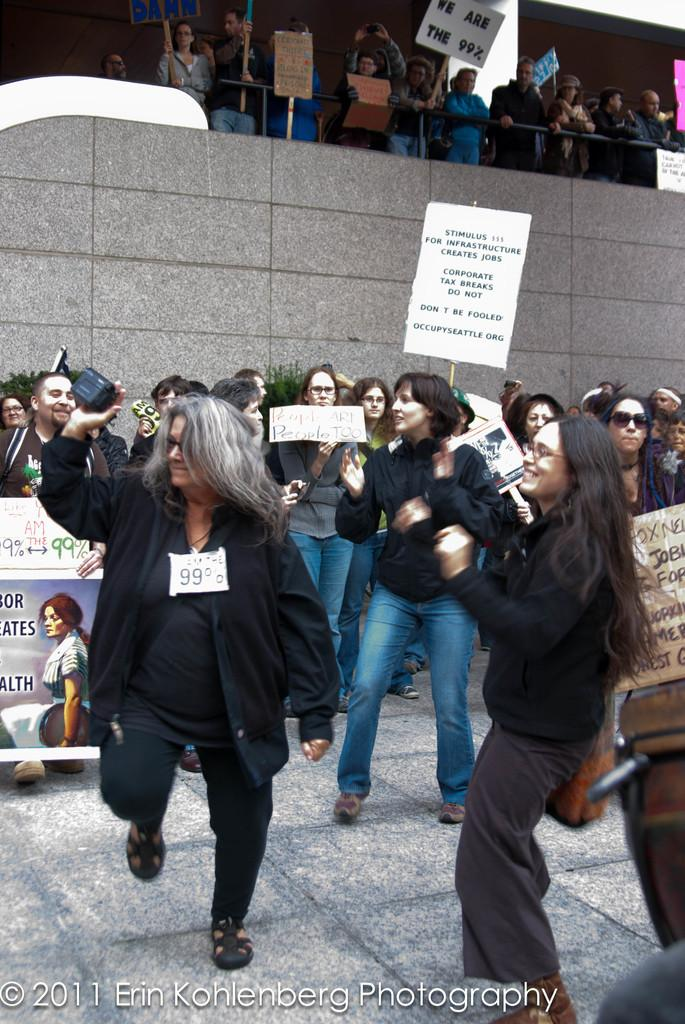How many people are in the image? There are people in the image, but the exact number is not specified. What are some of the people doing in the image? Some of the people are holding play cards in the image. What can be seen on the board in the image? The information about the board is not provided in the facts. What is written at the left bottom of the image? There is text at the left bottom of the image, but its content is not specified. What type of structure is visible in the image? There is a wall in the image. What type of yam is being used as a science experiment in the image? There is no yam or science experiment present in the image. How many bags of popcorn are visible on the wall in the image? There is no mention of popcorn or bags in the image. 